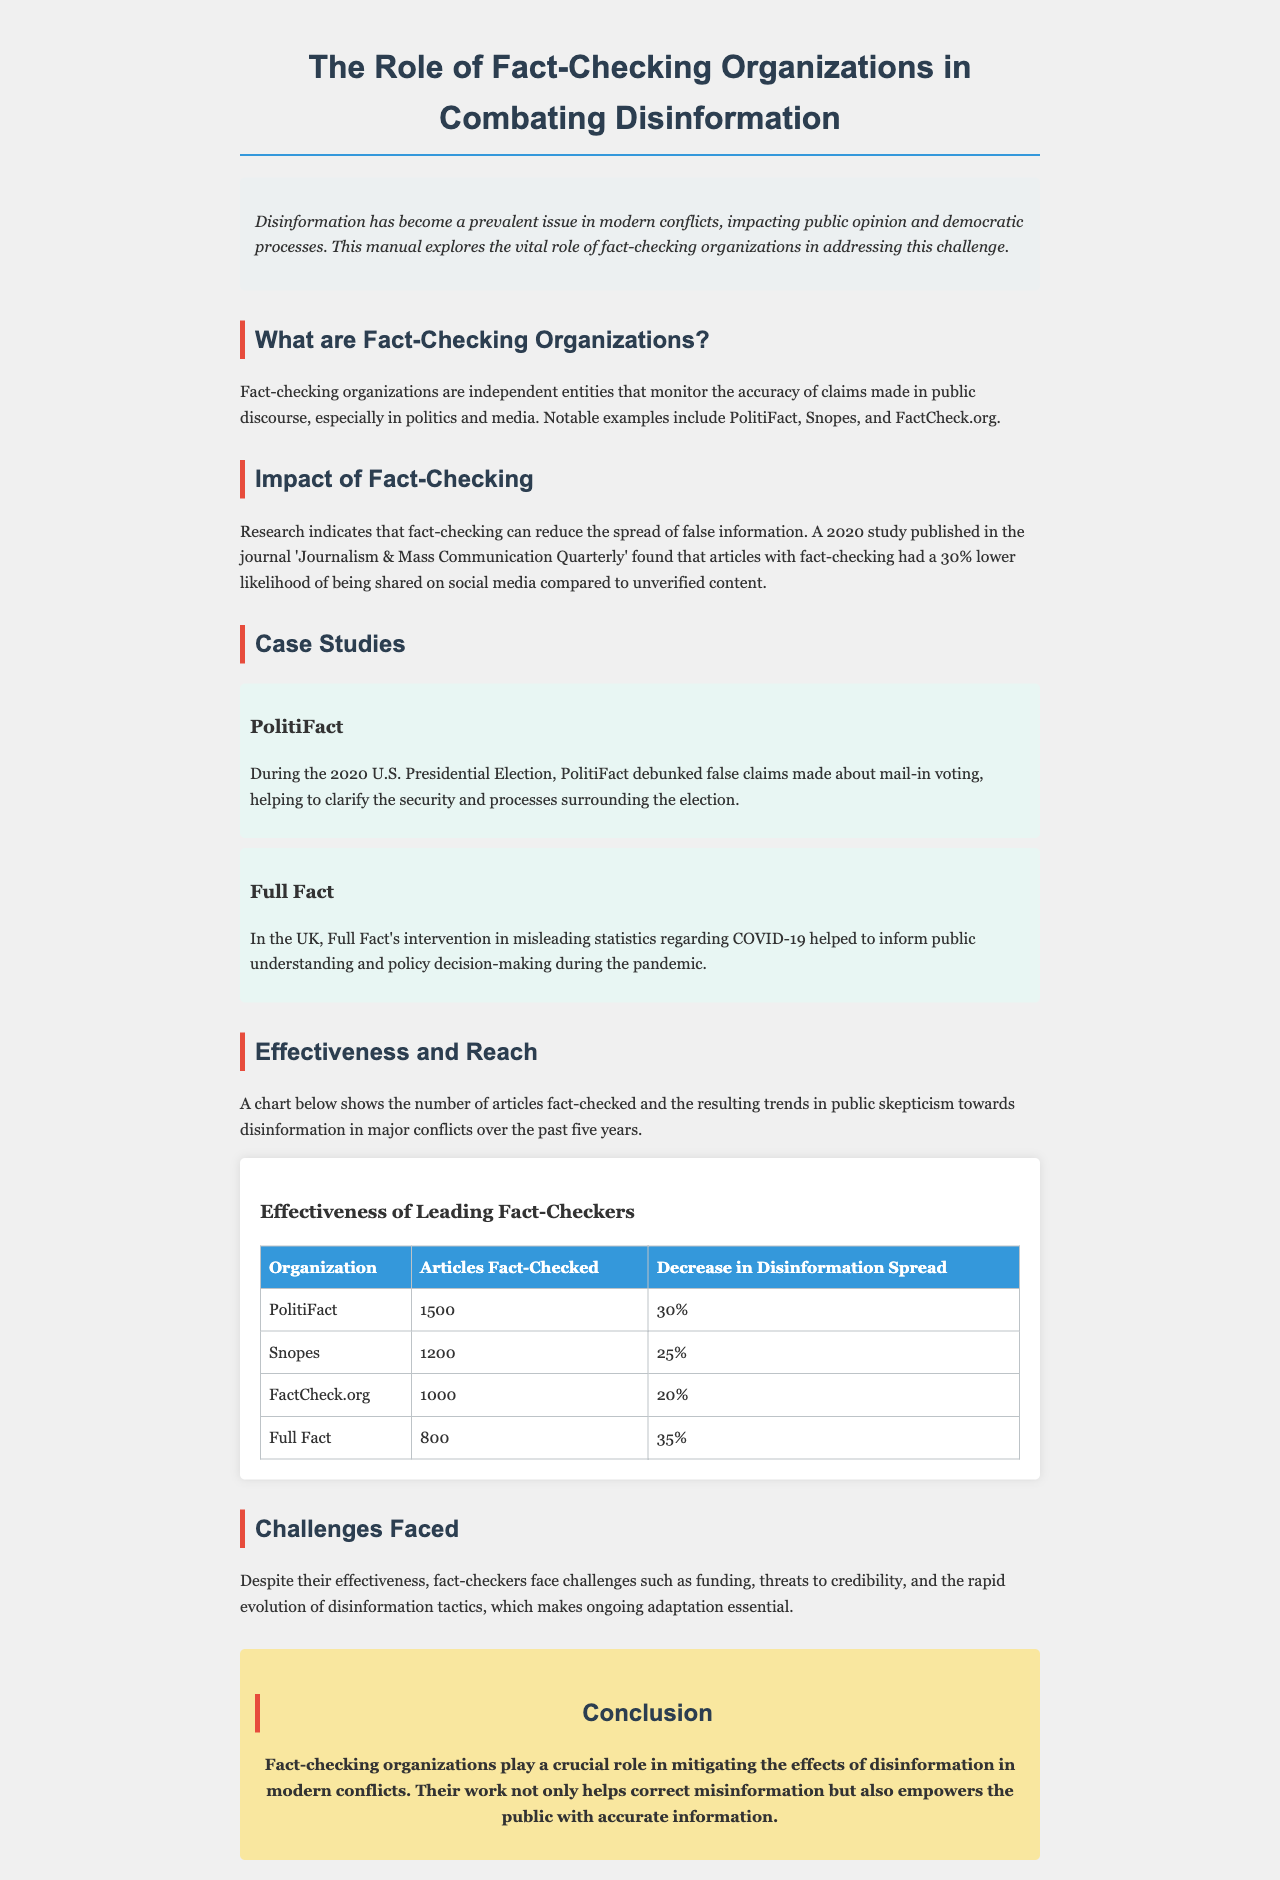What are examples of fact-checking organizations? The document lists notable examples of fact-checking organizations such as PolitiFact, Snopes, and FactCheck.org.
Answer: PolitiFact, Snopes, FactCheck.org What percentage decrease in disinformation spread does Full Fact achieve? In the effectiveness table, Full Fact shows a 35% decrease in disinformation spread.
Answer: 35% How many articles did Snopes fact-check? The effectiveness table states that Snopes has fact-checked a total of 1200 articles.
Answer: 1200 What is the primary challenge faced by fact-checkers mentioned in the document? The document highlights funding as one of the primary challenges faced by fact-checkers.
Answer: Funding What was the impact of PolitiFact during the 2020 U.S. Presidential Election? PolitiFact's impact included debunking false claims about mail-in voting.
Answer: Debunking false claims about mail-in voting What is the main role of fact-checking organizations? The document explains that the main role is to monitor the accuracy of claims made in public discourse.
Answer: Monitor accuracy of claims What is the effectiveness of fact-checking according to the 2020 study? The study found that articles with fact-checking had a 30% lower likelihood of being shared on social media compared to unverified content.
Answer: 30% lower likelihood Which fact-checking organization had the highest number of articles fact-checked? The effectiveness table shows that PolitiFact had the highest number of articles fact-checked, totaling 1500 articles.
Answer: PolitiFact 